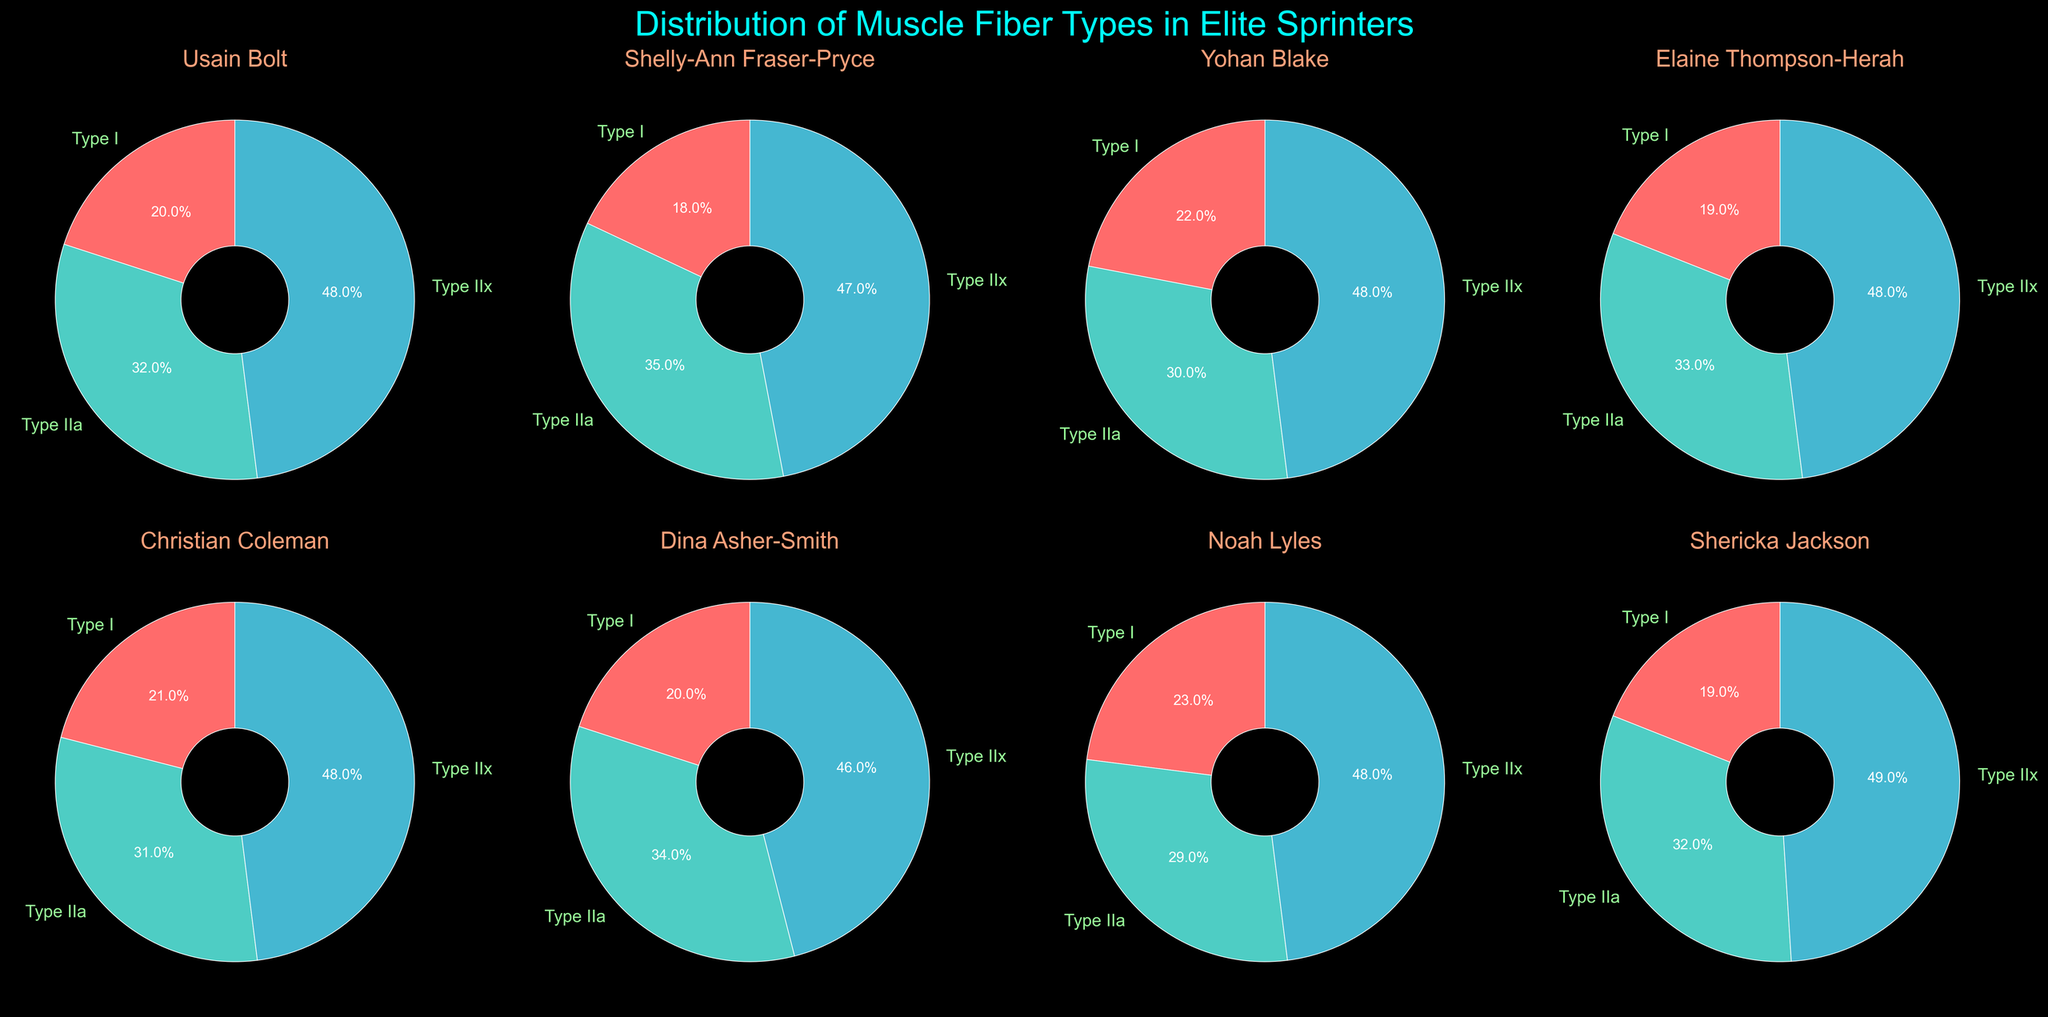What is the title of the figure? The title of the figure is located at the top and provides a description of the overall content.
Answer: Distribution of Muscle Fiber Types in Elite Sprinters Which muscle fiber type has the largest percentage in Shelly-Ann Fraser-Pryce's pie chart? By examining Shelly-Ann Fraser-Pryce's pie chart, you can observe the relative sizes of the slices. The largest slice represents Type IIa fibers.
Answer: Type IIa How many athletes have exactly 48% of Type IIx fibers? To answer this, count the number of pie charts with a slice showing 48% for Type IIx fibers. Usain Bolt, Yohan Blake, Elaine Thompson-Herah, Christian Coleman, and Noah Lyles all have 48% for Type IIx fibers, totaling five athletes.
Answer: Five Which athlete has the highest percentage of Type IIx fibers? Compare the percentages of Type IIx slices across all athletes' pie charts. Shericka Jackson has the highest percentage of Type IIx fibers with 49%.
Answer: Shericka Jackson Calculate the average percentage of Type I fibers across all athletes. Sum the percentages of Type I fibers for each athlete and divide by the number of athletes. The sum is 20 + 18 + 22 + 19 + 21 + 20 + 23 + 19 = 162. Dividing 162 by 8 athletes gives an average of 20.25%.
Answer: 20.25% What is the sum of Type IIa fibers for Usain Bolt and Elaine Thompson-Herah? Add the percentages of Type IIa fibers for both athletes: Usain Bolt has 32% and Elaine Thompson-Herah has 33%. The sum is 32% + 33% = 65%.
Answer: 65% Which athlete has the smallest percentage of Type IIa fibers? Look at the pie charts and find the athlete with the smallest slice for Type IIa fibers. Noah Lyles has the smallest percentage at 29%.
Answer: Noah Lyles What is the difference in the percentage of Type I fibers between Usain Bolt and Yohan Blake? Subtract the percentage of Type I fibers for Usain Bolt from that of Yohan Blake. Yohan Blake has 22% and Usain Bolt has 20%, resulting in a difference of 2%.
Answer: 2% Among the athletes shown, who has a higher percentage of Type IIa fibers, Shelly-Ann Fraser-Pryce or Dina Asher-Smith? Compare the percentage of Type IIa fibers between the two athletes. Shelly-Ann Fraser-Pryce has 35%, while Dina Asher-Smith has 34%. Therefore, Shelly-Ann Fraser-Pryce has a higher percentage.
Answer: Shelly-Ann Fraser-Pryce Which type of muscle fibers is most predominant across all athletes? Examine the majority of the largest slices in each pie chart. Type IIx fibers tend to be the most predominant as they frequently appear as the largest slice in the majority of the athletes' pie charts.
Answer: Type IIx 